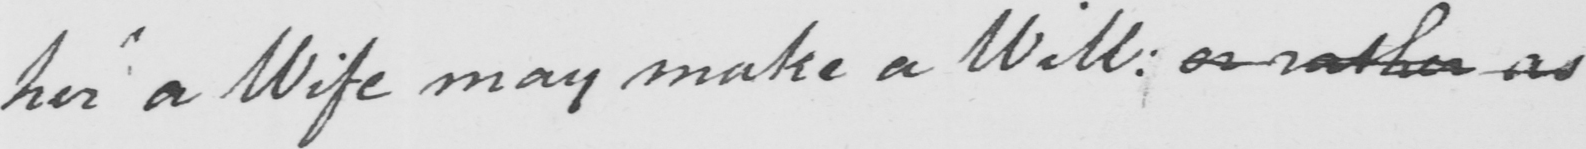Can you read and transcribe this handwriting? her a Wife may make a Will: or rather as 